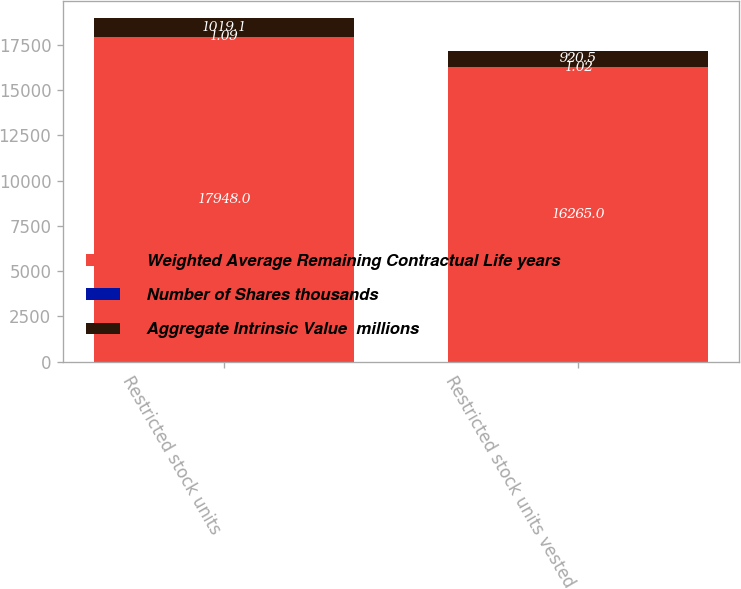Convert chart to OTSL. <chart><loc_0><loc_0><loc_500><loc_500><stacked_bar_chart><ecel><fcel>Restricted stock units<fcel>Restricted stock units vested<nl><fcel>Weighted Average Remaining Contractual Life years<fcel>17948<fcel>16265<nl><fcel>Number of Shares thousands<fcel>1.09<fcel>1.02<nl><fcel>Aggregate Intrinsic Value  millions<fcel>1019.1<fcel>920.5<nl></chart> 